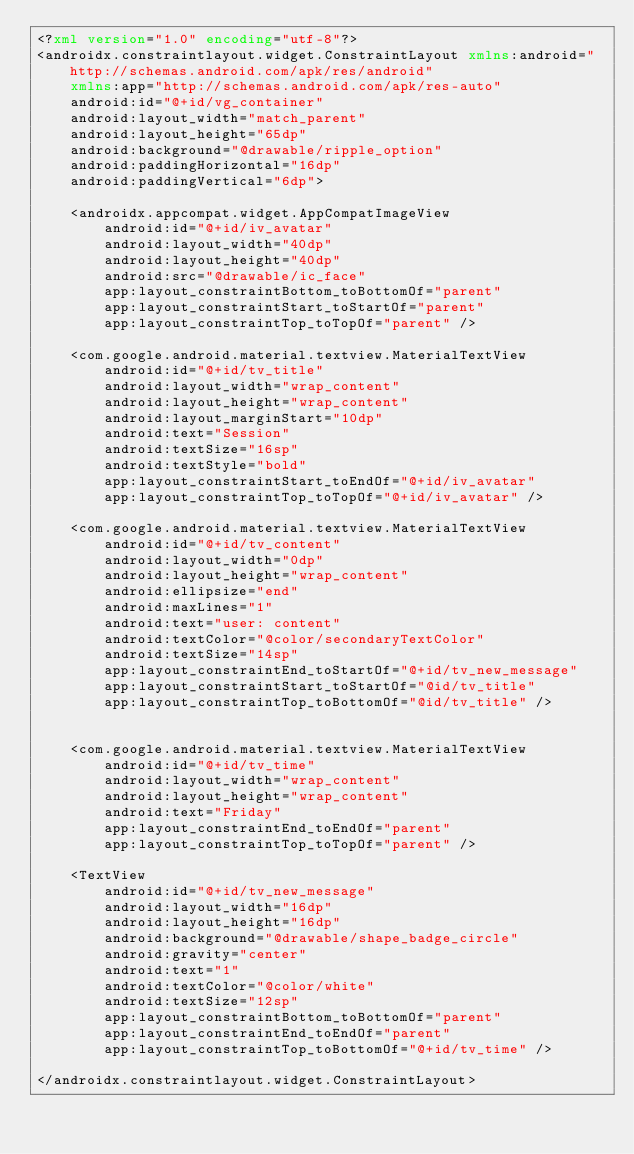<code> <loc_0><loc_0><loc_500><loc_500><_XML_><?xml version="1.0" encoding="utf-8"?>
<androidx.constraintlayout.widget.ConstraintLayout xmlns:android="http://schemas.android.com/apk/res/android"
    xmlns:app="http://schemas.android.com/apk/res-auto"
    android:id="@+id/vg_container"
    android:layout_width="match_parent"
    android:layout_height="65dp"
    android:background="@drawable/ripple_option"
    android:paddingHorizontal="16dp"
    android:paddingVertical="6dp">

    <androidx.appcompat.widget.AppCompatImageView
        android:id="@+id/iv_avatar"
        android:layout_width="40dp"
        android:layout_height="40dp"
        android:src="@drawable/ic_face"
        app:layout_constraintBottom_toBottomOf="parent"
        app:layout_constraintStart_toStartOf="parent"
        app:layout_constraintTop_toTopOf="parent" />

    <com.google.android.material.textview.MaterialTextView
        android:id="@+id/tv_title"
        android:layout_width="wrap_content"
        android:layout_height="wrap_content"
        android:layout_marginStart="10dp"
        android:text="Session"
        android:textSize="16sp"
        android:textStyle="bold"
        app:layout_constraintStart_toEndOf="@+id/iv_avatar"
        app:layout_constraintTop_toTopOf="@+id/iv_avatar" />

    <com.google.android.material.textview.MaterialTextView
        android:id="@+id/tv_content"
        android:layout_width="0dp"
        android:layout_height="wrap_content"
        android:ellipsize="end"
        android:maxLines="1"
        android:text="user: content"
        android:textColor="@color/secondaryTextColor"
        android:textSize="14sp"
        app:layout_constraintEnd_toStartOf="@+id/tv_new_message"
        app:layout_constraintStart_toStartOf="@id/tv_title"
        app:layout_constraintTop_toBottomOf="@id/tv_title" />


    <com.google.android.material.textview.MaterialTextView
        android:id="@+id/tv_time"
        android:layout_width="wrap_content"
        android:layout_height="wrap_content"
        android:text="Friday"
        app:layout_constraintEnd_toEndOf="parent"
        app:layout_constraintTop_toTopOf="parent" />

    <TextView
        android:id="@+id/tv_new_message"
        android:layout_width="16dp"
        android:layout_height="16dp"
        android:background="@drawable/shape_badge_circle"
        android:gravity="center"
        android:text="1"
        android:textColor="@color/white"
        android:textSize="12sp"
        app:layout_constraintBottom_toBottomOf="parent"
        app:layout_constraintEnd_toEndOf="parent"
        app:layout_constraintTop_toBottomOf="@+id/tv_time" />

</androidx.constraintlayout.widget.ConstraintLayout></code> 